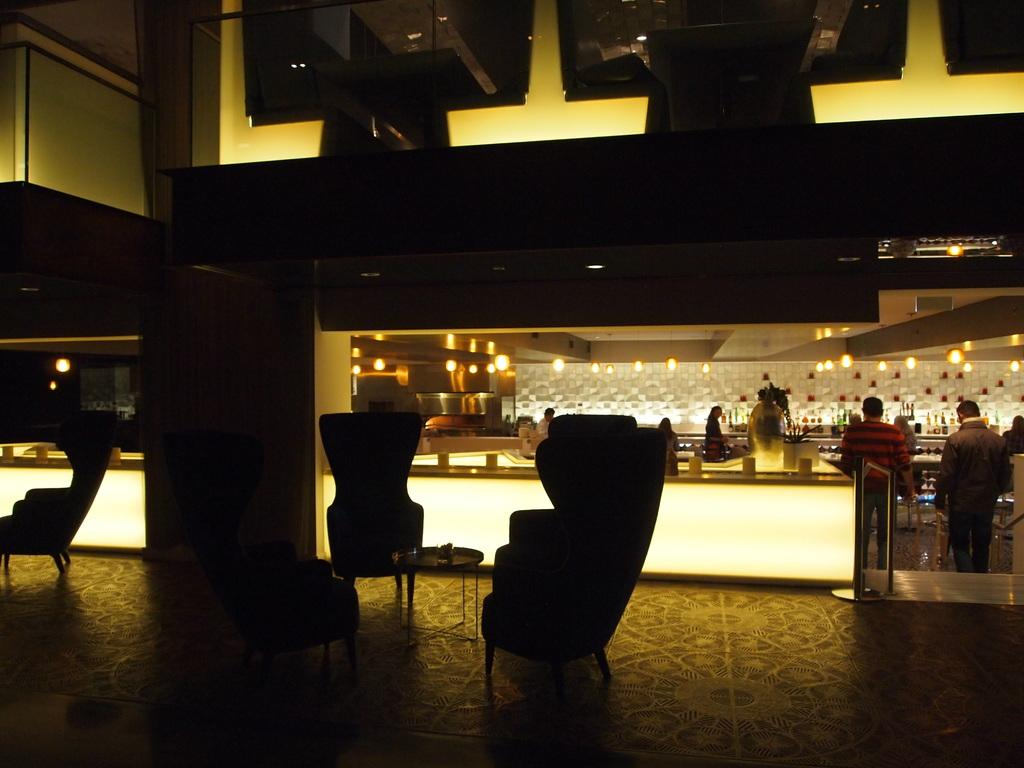What type of furniture can be seen in the image? There are chairs and tables in the image. Who or what is present in the image? There are people in the image. Where is the setting of the image? The setting is in the lobby of a restaurant. What type of lace is being used to decorate the chairs in the image? There is no lace present in the image; the chairs are not decorated with lace. What type of yarn is being used to knit a sweater by the laborer in the image? There is no laborer or sweater being knitted in the image. 